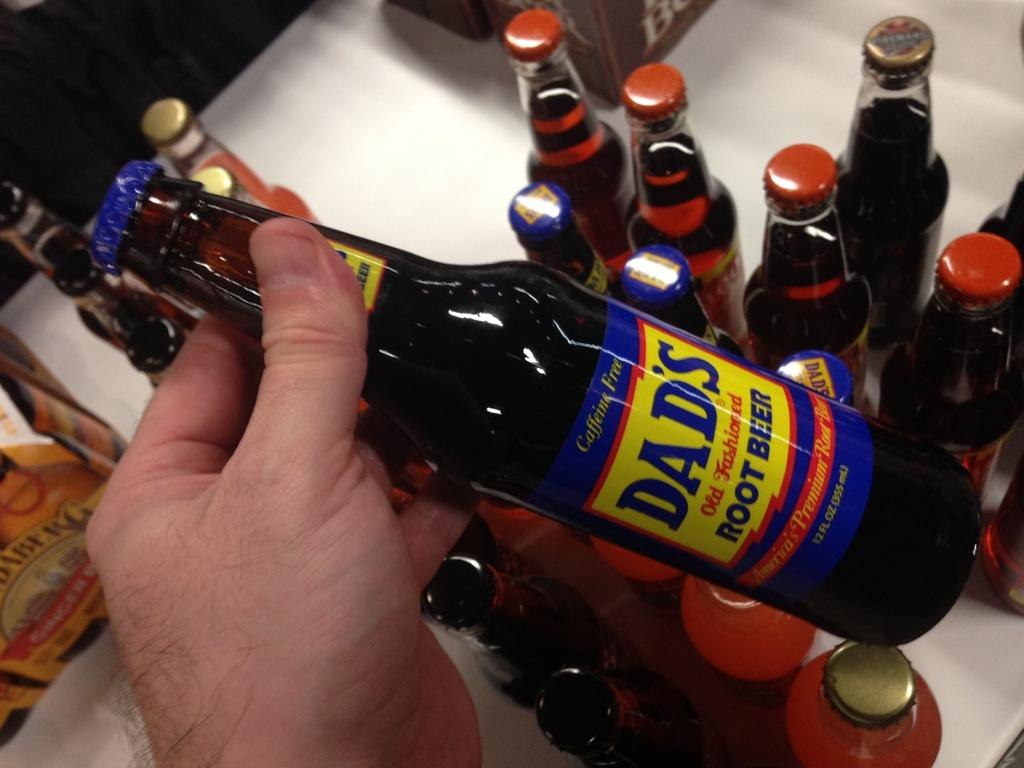<image>
Render a clear and concise summary of the photo. A person holding a bottle of Dad's Root Beer. 